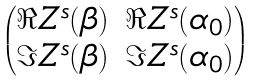<formula> <loc_0><loc_0><loc_500><loc_500>\begin{pmatrix} \Re Z ^ { s } ( \beta ) & \Re Z ^ { s } ( \alpha _ { 0 } ) \\ \Im Z ^ { s } ( \beta ) & \Im Z ^ { s } ( \alpha _ { 0 } ) \end{pmatrix}</formula> 